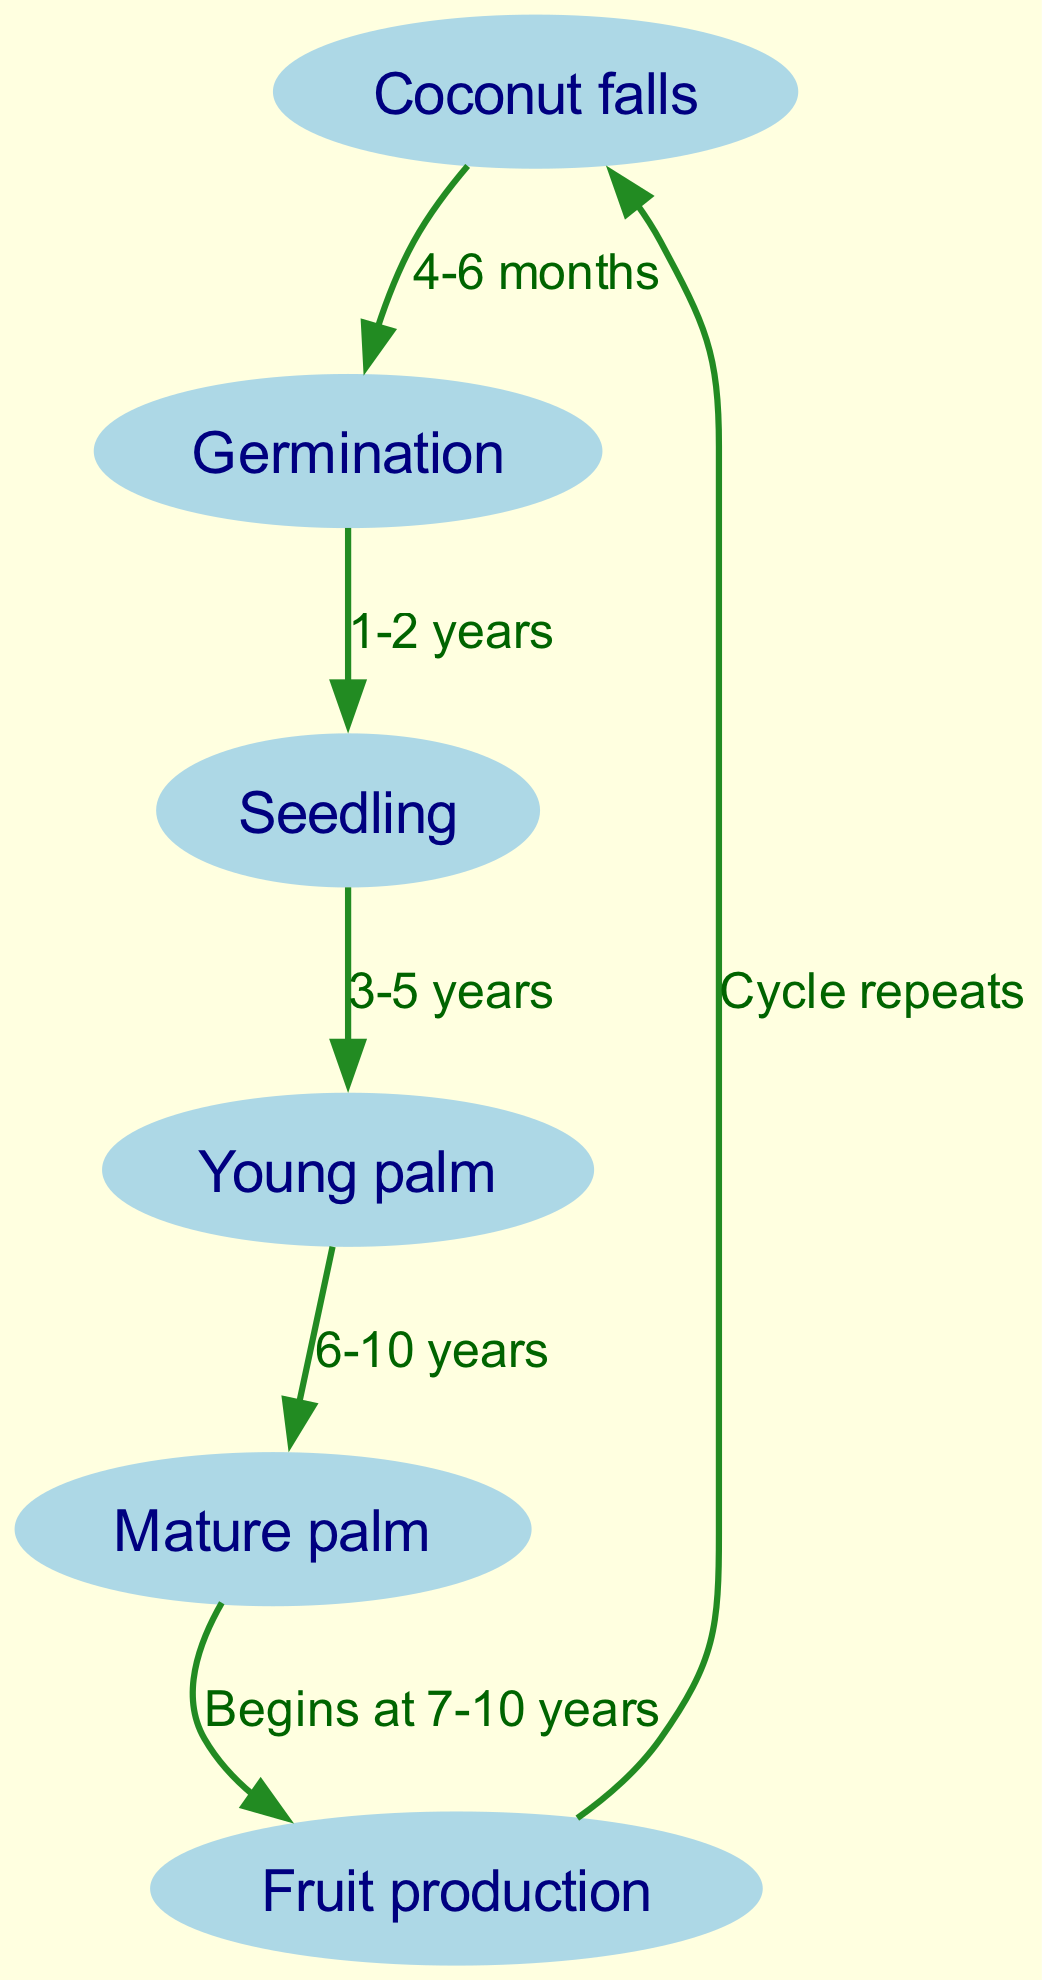What is the first step in the life cycle of a coconut palm? The diagram indicates that the life cycle begins with "Coconut falls," which represents the starting point before any further development.
Answer: Coconut falls How many years does it take to reach the "Mature palm" stage? According to the diagram, the transition from "Young palm" to "Mature palm" occurs in 6-10 years, indicating a range of years needed to reach maturity.
Answer: 6-10 years What stage comes after "Seedling"? The diagram specifies that after "Seedling," the next stage in the life cycle is "Young palm." This is a direct movement from one node to the next as indicated by the path in the diagram.
Answer: Young palm What process begins at 7-10 years? The diagram states that "Fruit production" begins at the age of 7-10 years of the "Mature palm," indicating that this is the timeframe after reaching maturity for fruit-bearing.
Answer: Fruit production How many nodes are there in the diagram? By counting the nodes listed in the diagram, there are a total of 6 distinct stages described as nodes in the life cycle of a coconut palm.
Answer: 6 What is the time period from "Coconut falls" to "Germination"? The diagram specifies that the time taken for a coconut to go from "Coconut falls" to "Germination" is approximately 4-6 months. This time range defines the initial growth phase before the plant begins to sprout.
Answer: 4-6 months Which stage follows "Mature palm"? The next stage after "Mature palm" in the cycle, as shown by the diagram, is "Fruit production." This indicates a transition to the productive life of the coconut palm.
Answer: Fruit production What happens after "Fruit production"? According to the diagram, after "Fruit production," the cycle repeats itself, leading back to "Coconut falls." This indicates the cyclical nature of the coconut palm's life.
Answer: Cycle repeats 